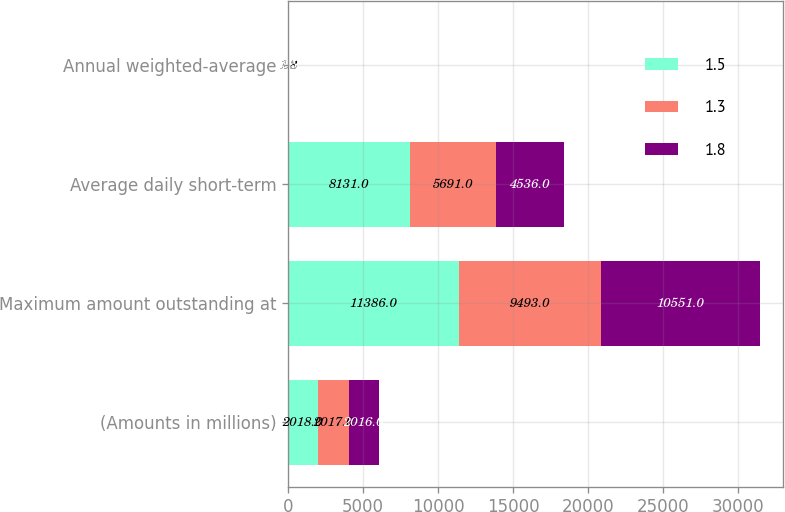Convert chart to OTSL. <chart><loc_0><loc_0><loc_500><loc_500><stacked_bar_chart><ecel><fcel>(Amounts in millions)<fcel>Maximum amount outstanding at<fcel>Average daily short-term<fcel>Annual weighted-average<nl><fcel>1.5<fcel>2018<fcel>11386<fcel>8131<fcel>1.3<nl><fcel>1.3<fcel>2017<fcel>9493<fcel>5691<fcel>1.8<nl><fcel>1.8<fcel>2016<fcel>10551<fcel>4536<fcel>1.5<nl></chart> 